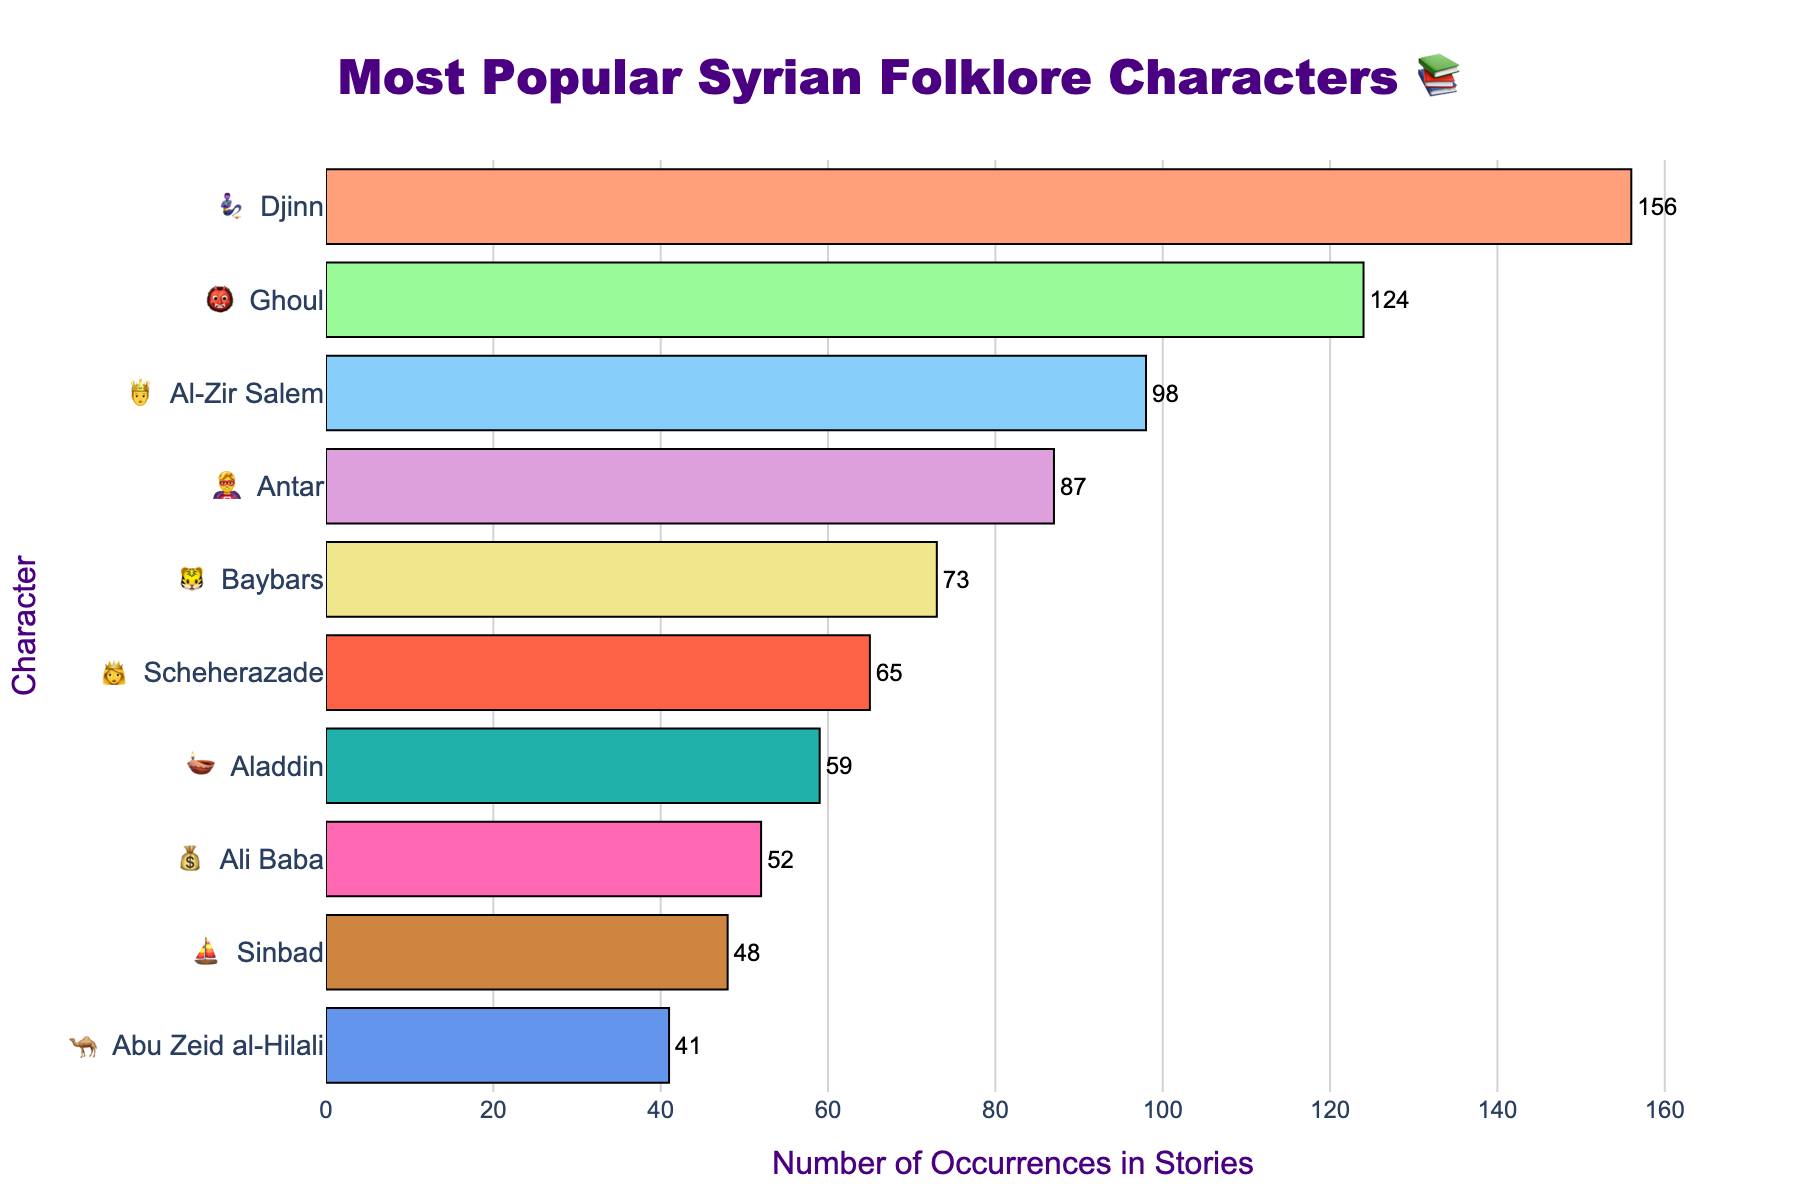What's the title of the figure? The title is prominently displayed at the top of the figure, stating what the chart is about. In this case, it is "Most Popular Syrian Folklore Characters 📚".
Answer: Most Popular Syrian Folklore Characters 📚 How many characters are listed in the chart? We count all the unique characters listed on the y-axis. The chart shows 10 different folklore characters.
Answer: 10 Which character appears the most in stories? The bar representing "Djinn" is the longest, indicating it has the highest number of occurrences.
Answer: Djinn How many times does Aladdin appear in stories? We find the "Aladdin" bar on the chart and check the number next to it.
Answer: 59 What is the range of occurrences for these characters? We look at the highest and lowest numbers of occurrences in the chart. "Djinn" has 156, and "Abu Zeid al-Hilali" shows 41. Thus, the range is 156 - 41 = 115.
Answer: 115 Which character appears more frequently: Antar or Baybars? Locate both "Antar" and "Baybars" on the chart. Antar has 87 occurrences, while Baybars has 73. "Antar" appears more frequently than "Baybars".
Answer: Antar What is the total number of occurrences for the top three characters? Sum the occurrences for "Djinn", "Ghoul", and "Al-Zir Salem". 156 + 124 + 98 = 378.
Answer: 378 How many occurrences are there for characters that appear fewer times than Sinbad? Sum the occurrences for characters after "Sinbad". "Abu Zeid al-Hilali" has 41 occurrences.
Answer: 41 What is the average number of occurrences for all characters in the chart? Sum all occurrences and divide by the number of characters: (156 + 124 + 98 + 87 + 73 + 65 + 59 + 52 + 48 + 41) / 10 = 80.3.
Answer: 80.3 Which characters have more than 90 occurrences? Identify bars exceeding the 90-mark. "Djinn", "Ghoul", and "Al-Zir Salem" have more than 90 occurrences.
Answer: Djinn, Ghoul, Al-Zir Salem 